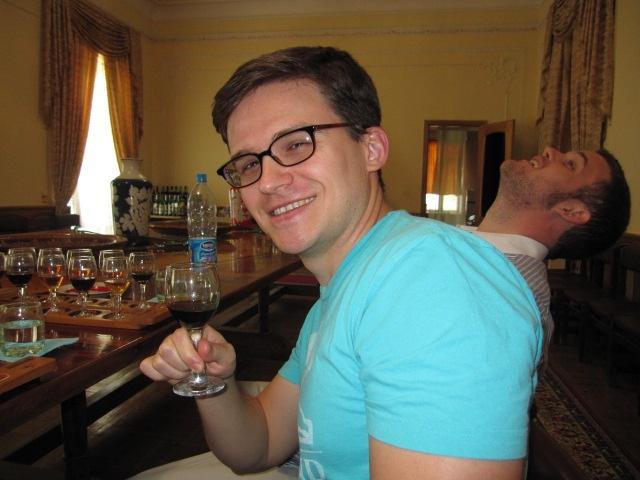Is the man's shirt long sleeve?
Give a very brief answer. No. Is the man holding a glass?
Write a very short answer. Yes. What are both of the men doing?
Short answer required. Drinking. What color is the water bottle?
Give a very brief answer. Clear. Could that be soda in the bottle?
Keep it brief. No. 